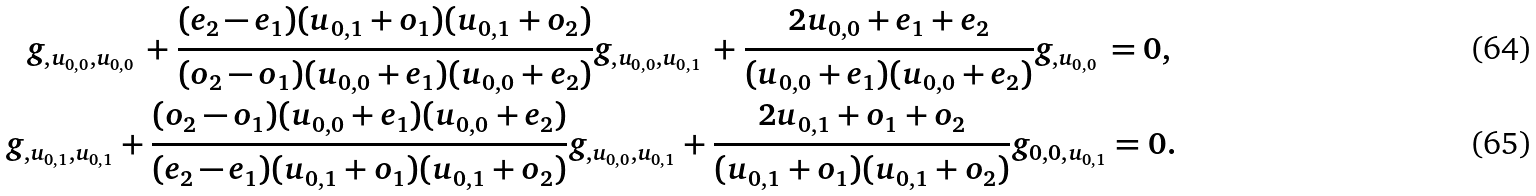<formula> <loc_0><loc_0><loc_500><loc_500>g _ { , u _ { 0 , 0 } , u _ { 0 , 0 } } \, + \frac { ( e _ { 2 } - e _ { 1 } ) ( u _ { 0 , 1 } + o _ { 1 } ) ( u _ { 0 , 1 } + o _ { 2 } ) } { ( o _ { 2 } - o _ { 1 } ) ( u _ { 0 , 0 } + e _ { 1 } ) ( u _ { 0 , 0 } + e _ { 2 } ) } g _ { , u _ { 0 , 0 } , u _ { 0 , 1 } } \, + \frac { 2 u _ { 0 , 0 } + e _ { 1 } + e _ { 2 } } { ( u _ { 0 , 0 } + e _ { 1 } ) ( u _ { 0 , 0 } + e _ { 2 } ) } g _ { , u _ { 0 , 0 } } \, = 0 , \, \\ g _ { , u _ { 0 , 1 } , u _ { 0 , 1 } } + \frac { ( o _ { 2 } - o _ { 1 } ) ( u _ { 0 , 0 } + e _ { 1 } ) ( u _ { 0 , 0 } + e _ { 2 } ) } { ( e _ { 2 } - e _ { 1 } ) ( u _ { 0 , 1 } + o _ { 1 } ) ( u _ { 0 , 1 } + o _ { 2 } ) } g _ { , u _ { 0 , 0 } , u _ { 0 , 1 } } + \frac { 2 u _ { 0 , 1 } + o _ { 1 } + o _ { 2 } } { ( u _ { 0 , 1 } + o _ { 1 } ) ( u _ { 0 , 1 } + o _ { 2 } ) } g _ { 0 , 0 , u _ { 0 , 1 } } = 0 .</formula> 